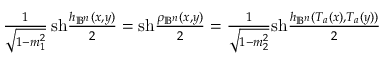Convert formula to latex. <formula><loc_0><loc_0><loc_500><loc_500>\begin{array} { r } { \frac { 1 } { \sqrt { 1 - m _ { 1 } ^ { 2 } } } \, s h \frac { h _ { \mathbb { B } ^ { n } } ( x , y ) } { 2 } = s h \frac { \rho _ { \mathbb { B } ^ { n } } ( x , y ) } { 2 } = \frac { 1 } { \sqrt { 1 - m _ { 2 } ^ { 2 } } } s h \frac { h _ { \mathbb { B } ^ { n } } ( T _ { a } ( x ) , T _ { a } ( y ) ) } { 2 } } \end{array}</formula> 